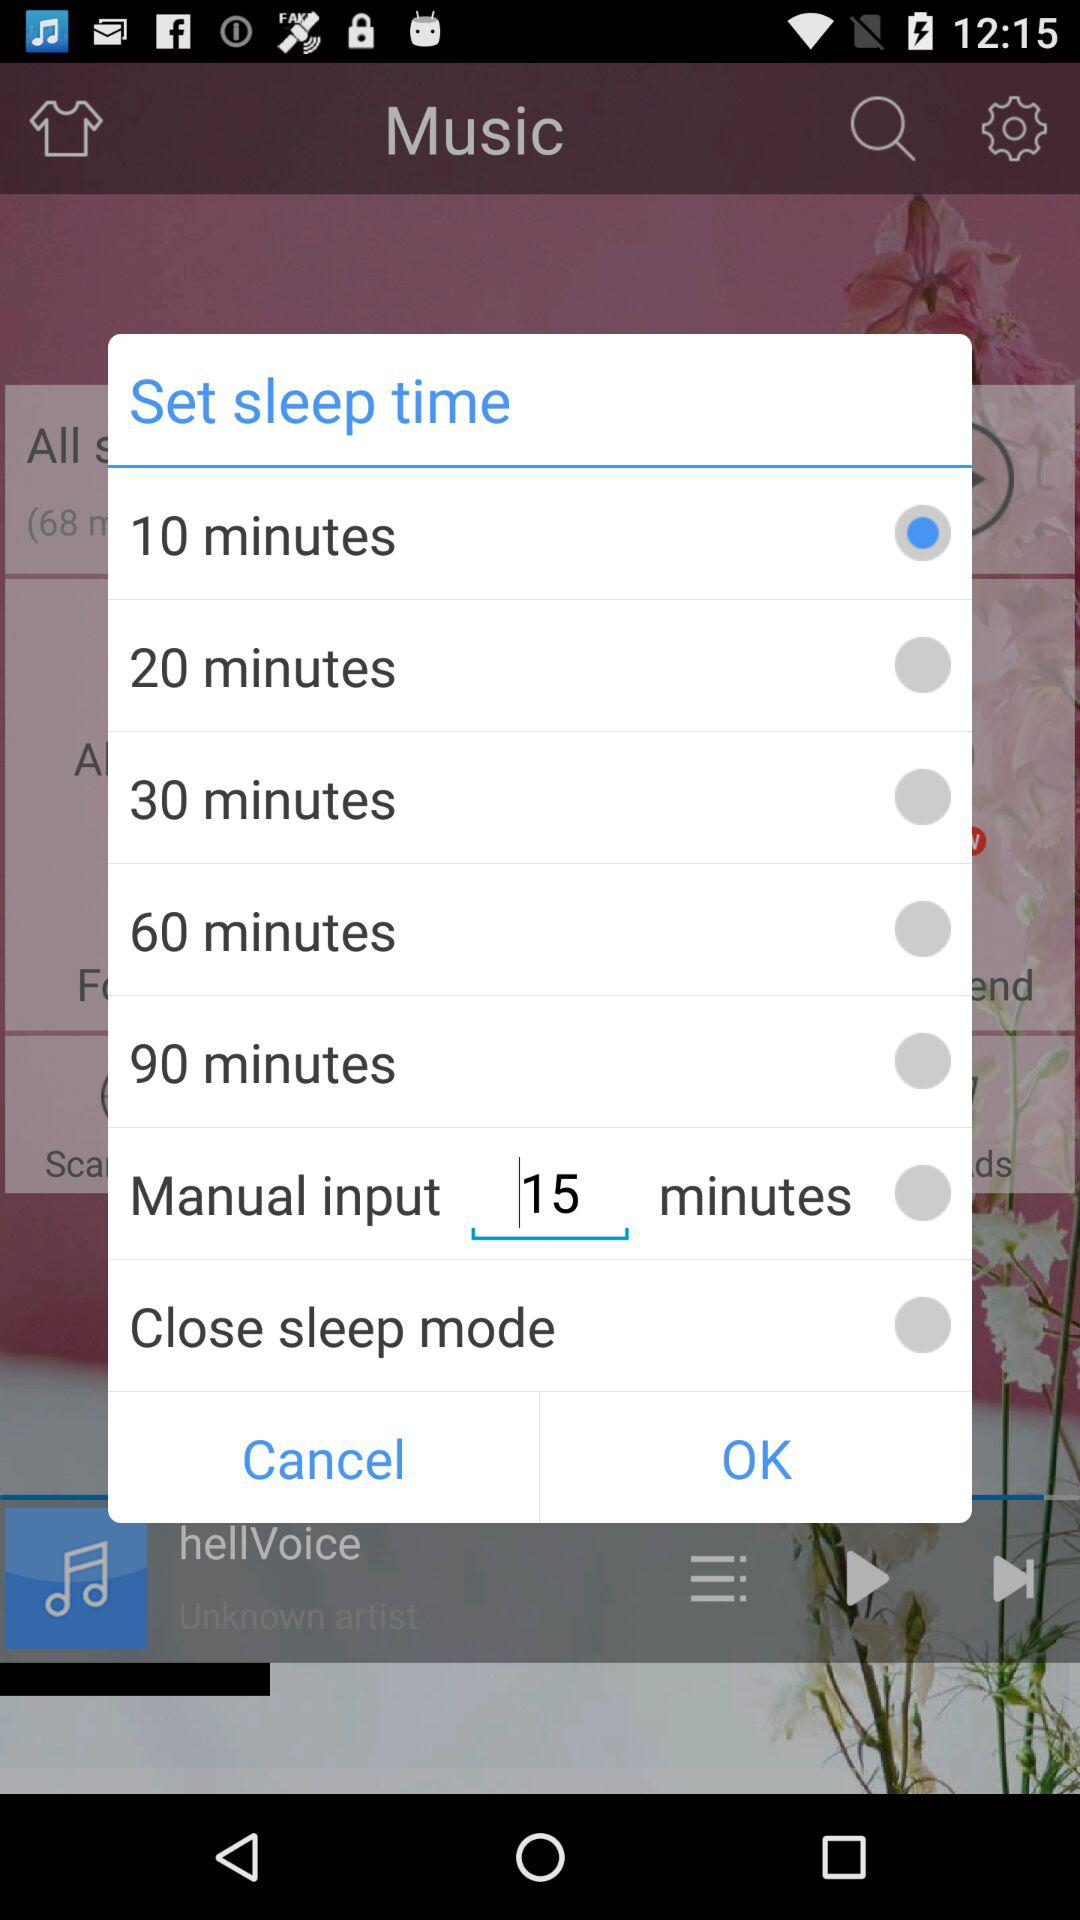What is the entered duration in "Manual input" in minutes? The entered duration in "Manual input" in minutes is 15. 